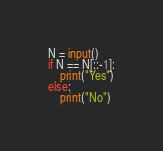<code> <loc_0><loc_0><loc_500><loc_500><_Python_>

N = input()
if N == N[::-1]:
    print("Yes")
else:
    print("No")</code> 